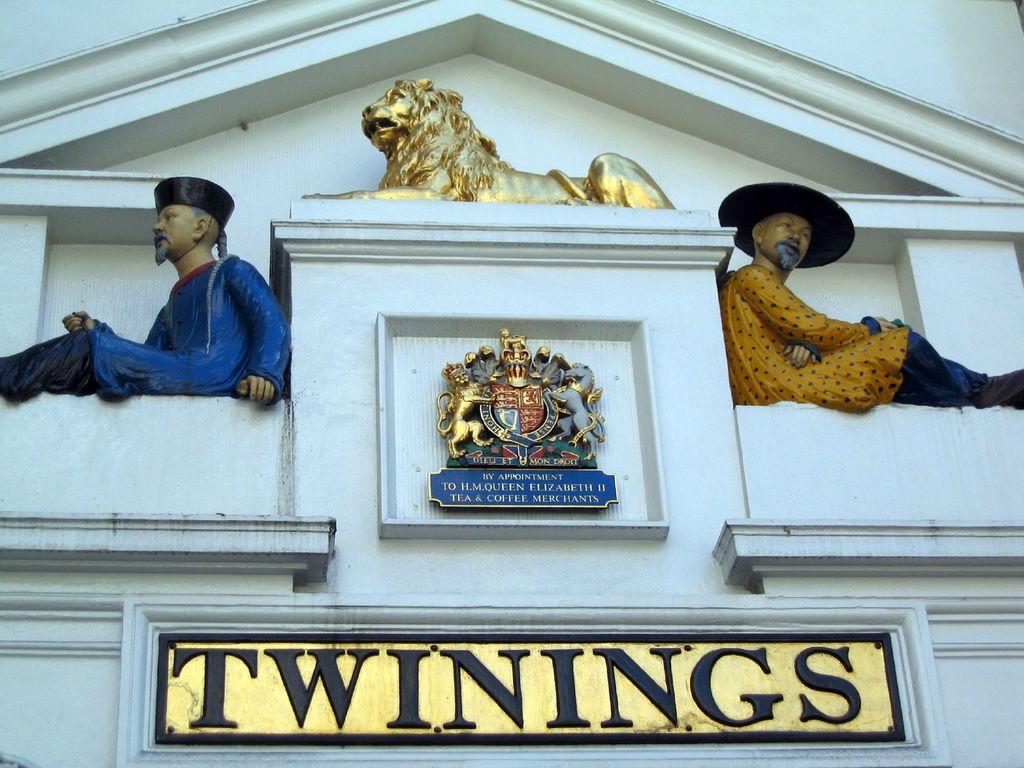Describe this image in one or two sentences. In the picture I can see the statue of an animal at the top of the picture. I can see the statue of a man on the left side and the right side. There is the logo on the wall. I can see the text on the wall at the bottom of the picture. 